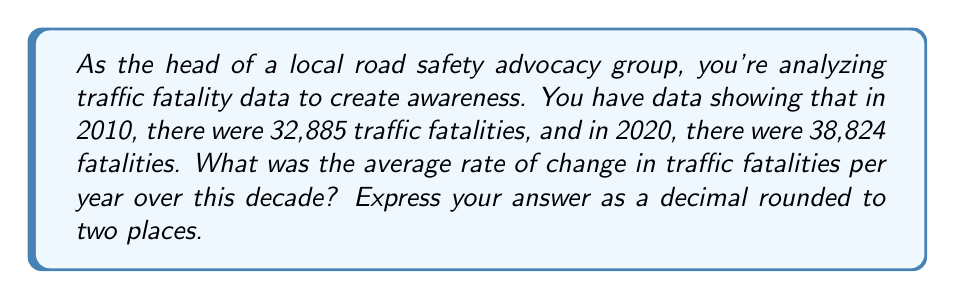What is the answer to this math problem? To find the average rate of change, we need to use the formula:

$$ \text{Rate of Change} = \frac{\text{Change in y}}{\text{Change in x}} $$

Where y represents the number of fatalities and x represents the time in years.

1) First, let's identify our points:
   $(x_1, y_1) = (2010, 32885)$
   $(x_2, y_2) = (2020, 38824)$

2) Now, let's calculate the change in y (fatalities):
   $\Delta y = y_2 - y_1 = 38824 - 32885 = 5939$

3) Calculate the change in x (years):
   $\Delta x = x_2 - x_1 = 2020 - 2010 = 10$ years

4) Apply the rate of change formula:
   $$ \text{Rate of Change} = \frac{\Delta y}{\Delta x} = \frac{5939}{10} = 593.9 $$

5) Round to two decimal places:
   $593.9$ rounds to $593.90$

This means that, on average, traffic fatalities increased by 593.90 per year over the decade from 2010 to 2020.
Answer: $593.90$ 